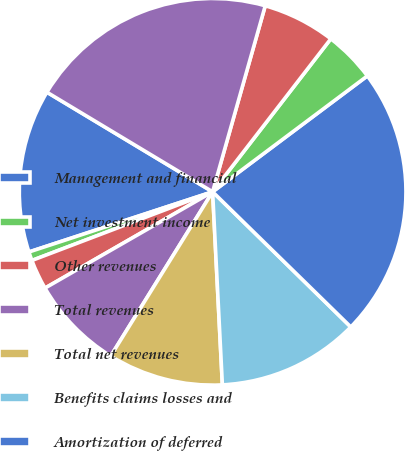Convert chart to OTSL. <chart><loc_0><loc_0><loc_500><loc_500><pie_chart><fcel>Management and financial<fcel>Net investment income<fcel>Other revenues<fcel>Total revenues<fcel>Total net revenues<fcel>Benefits claims losses and<fcel>Amortization of deferred<fcel>General and administrative<fcel>Total expenses<fcel>Income from continuing<nl><fcel>13.65%<fcel>0.74%<fcel>2.52%<fcel>7.86%<fcel>9.64%<fcel>11.87%<fcel>22.55%<fcel>4.3%<fcel>6.08%<fcel>20.77%<nl></chart> 